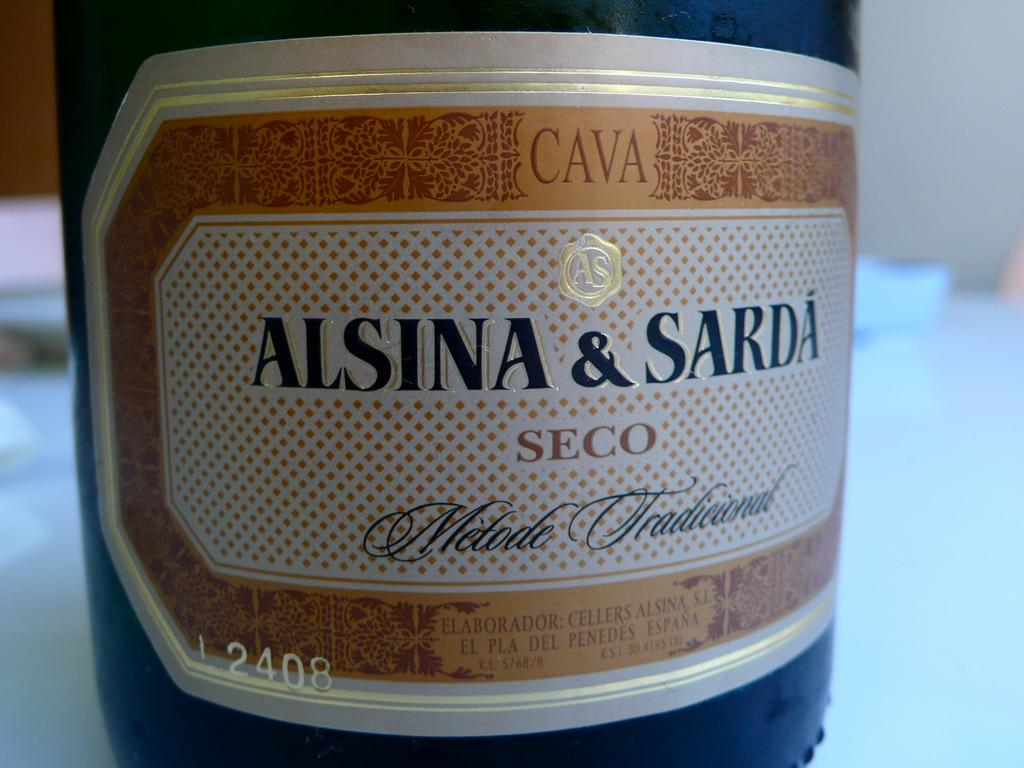<image>
Write a terse but informative summary of the picture. A bottle that reads "Alsina & Sarda" seco. 